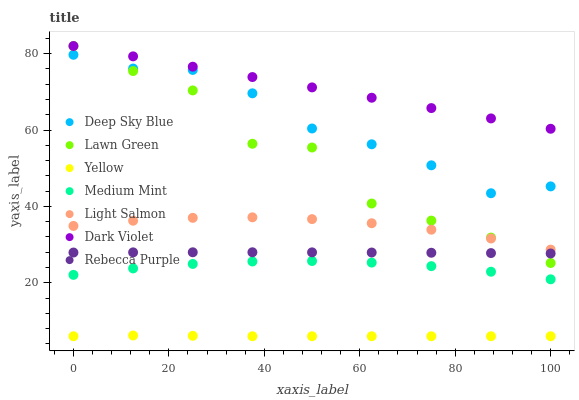Does Yellow have the minimum area under the curve?
Answer yes or no. Yes. Does Dark Violet have the maximum area under the curve?
Answer yes or no. Yes. Does Lawn Green have the minimum area under the curve?
Answer yes or no. No. Does Lawn Green have the maximum area under the curve?
Answer yes or no. No. Is Dark Violet the smoothest?
Answer yes or no. Yes. Is Lawn Green the roughest?
Answer yes or no. Yes. Is Light Salmon the smoothest?
Answer yes or no. No. Is Light Salmon the roughest?
Answer yes or no. No. Does Yellow have the lowest value?
Answer yes or no. Yes. Does Lawn Green have the lowest value?
Answer yes or no. No. Does Dark Violet have the highest value?
Answer yes or no. Yes. Does Light Salmon have the highest value?
Answer yes or no. No. Is Medium Mint less than Light Salmon?
Answer yes or no. Yes. Is Light Salmon greater than Rebecca Purple?
Answer yes or no. Yes. Does Lawn Green intersect Deep Sky Blue?
Answer yes or no. Yes. Is Lawn Green less than Deep Sky Blue?
Answer yes or no. No. Is Lawn Green greater than Deep Sky Blue?
Answer yes or no. No. Does Medium Mint intersect Light Salmon?
Answer yes or no. No. 